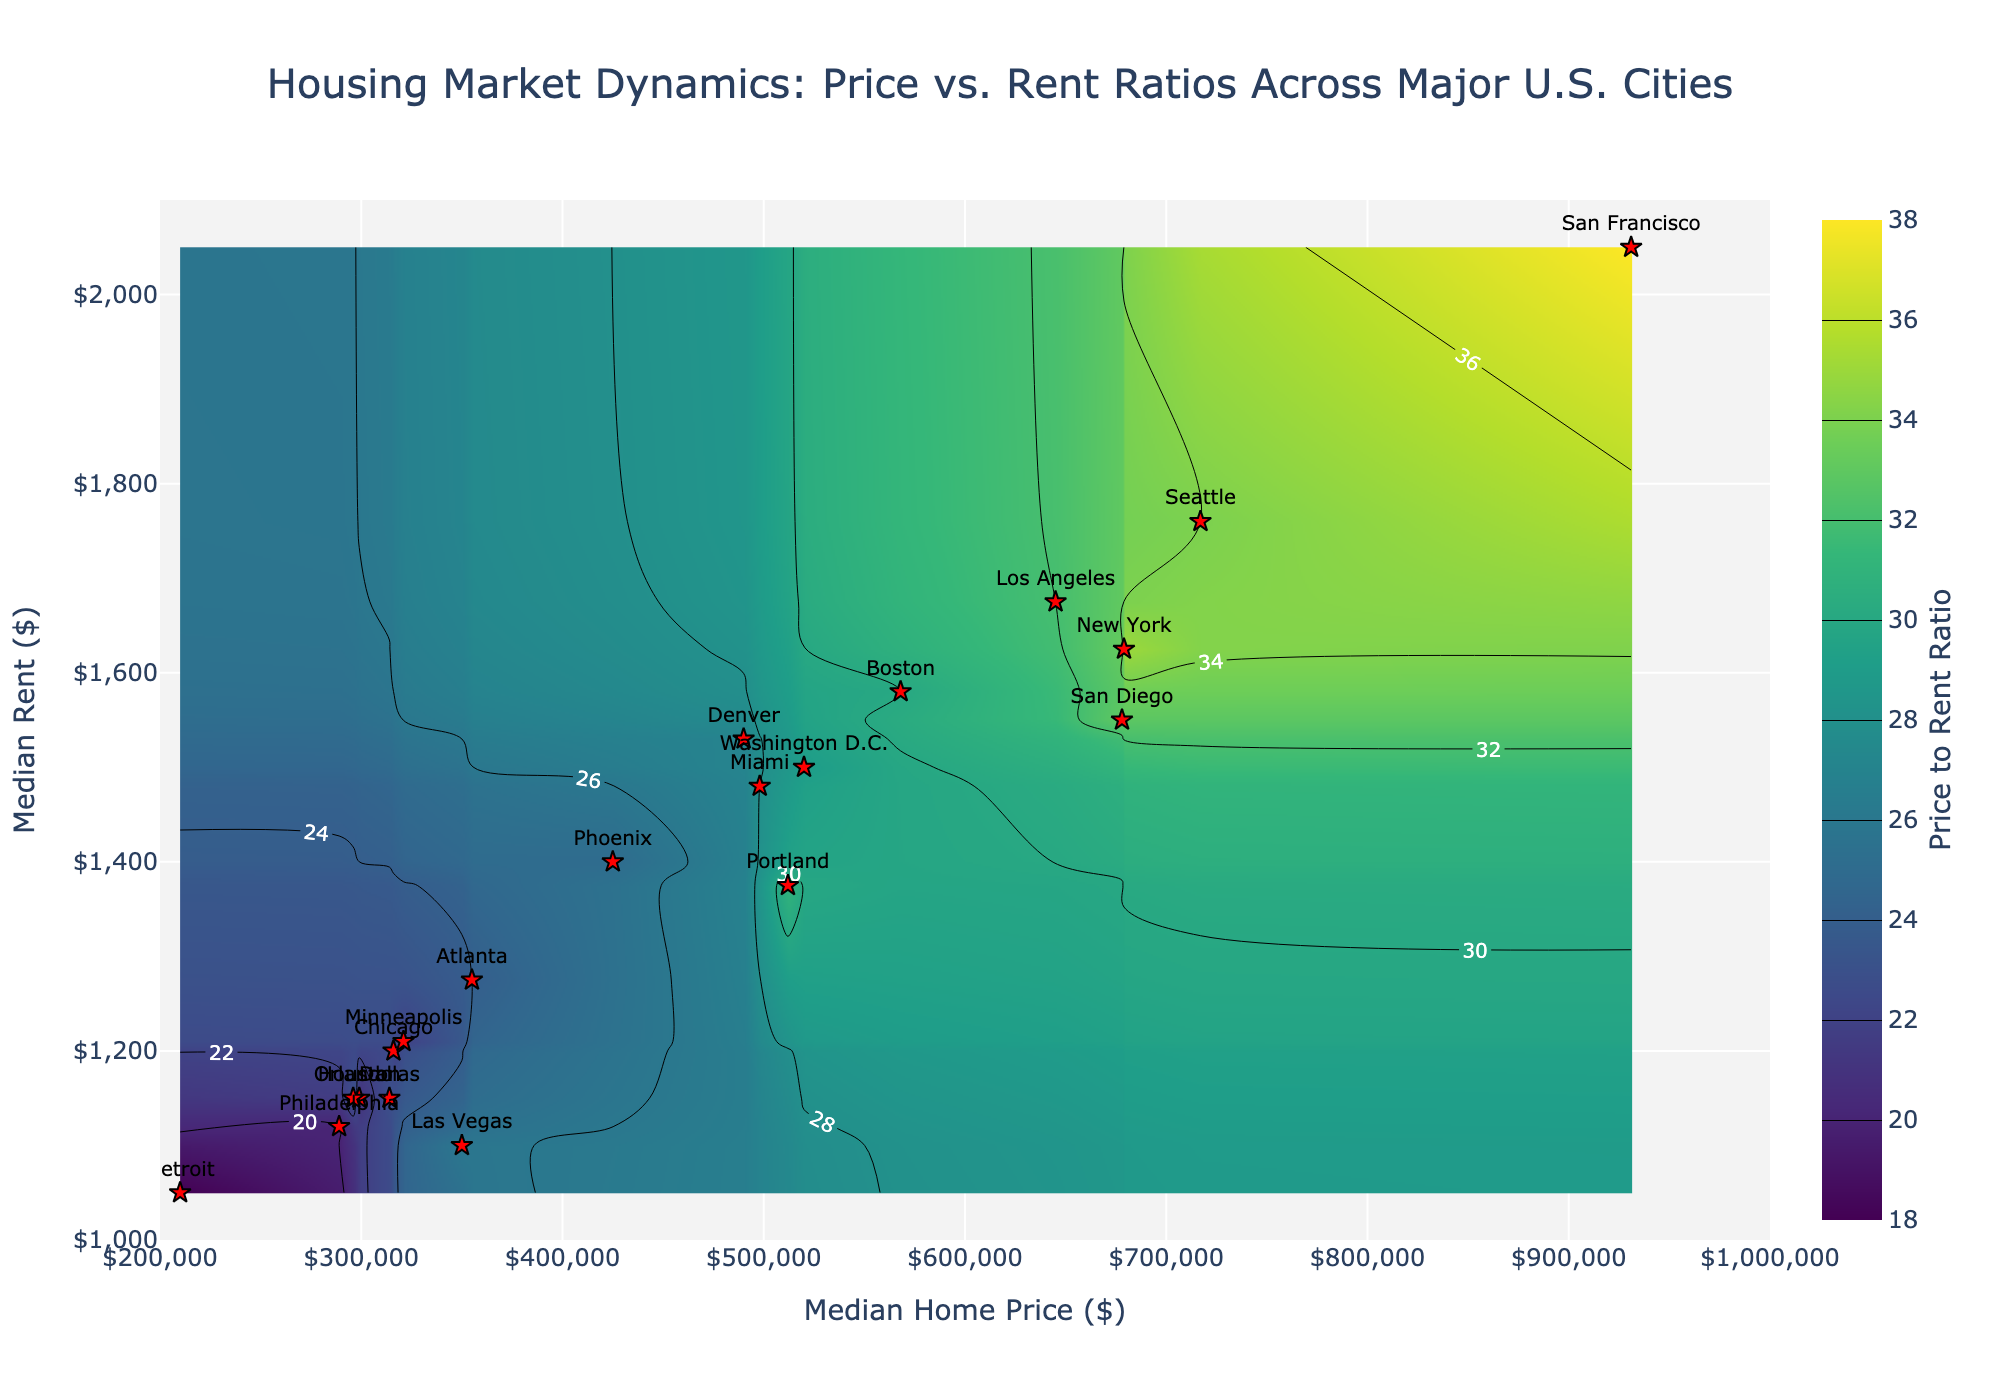What's the title of the figure? The title is typically located at the top center of the figure and provides an overview of the data being displayed. In this case, the title is "Housing Market Dynamics: Price vs. Rent Ratios Across Major U.S. Cities".
Answer: Housing Market Dynamics: Price vs. Rent Ratios Across Major U.S. Cities How many cities are represented in the figure? Each city is represented by a scatter point with its name labeled. Counting all the labeled points gives the number of cities.
Answer: 20 Which city has the highest Price to Rent Ratio? Locate the city marker in the region with the darkest color on the contour plot, indicating the highest Price to Rent Ratio. San Francisco and New York have high ratios, but San Francisco has a slightly higher ratio of 38.
Answer: San Francisco What is the Median Home Price in Las Vegas? Find the marker labeled "Las Vegas" and check the x-coordinate, which represents the Median Home Price on the horizontal axis.
Answer: 350000 What is the Median Rent in Orlando? Locate the marker labeled "Orlando" and then check its y-coordinate, which represents the Median Rent on the vertical axis.
Answer: 1150 Compare the Price to Rent Ratio of Chicago and Los Angeles. Which one is higher? Find the markers for Chicago and Los Angeles. Check the contour shades or the specific Price to Rent Ratio labels around these points. Chicago's ratio is 22, while Los Angeles is 32.
Answer: Los Angeles Which city has the lowest Price to Rent Ratio? Locate the city point in the area with the lightest shade on the contour plot, which indicates the lowest Price to Rent Ratio. Detroit has the lowest ratio of 18.
Answer: Detroit What are the Median Home Price and Median Rent values for New York? Locate the marker for New York and check its x-coordinate for Home Price and y-coordinate for Rent.
Answer: 679000, 1625 How does the Price to Rent Ratio of Phoenix compare to Miami? Check the contour values at the markers for Phoenix and Miami. Phoenix has a ratio of 25, and Miami has a ratio of 28. Miami has a higher ratio.
Answer: Miami Determine the average Price to Rent Ratio for cities with Median Home Prices between $300,000 and $500,000. Identify the cities with home prices in the range [$300,000, $500,000] (Chicago, Phoenix, Dallas, Philadelphia, Washington D.C., Miami, Las Vegas, Orlando, Minneapolis). The respective ratios are: 22, 25, 23, 20, 29, 28, 26, 23, 22. Sum them up and divide by the number of cities: (22+25+23+20+29+28+26+23+22)/9 = 24
Answer: 24 